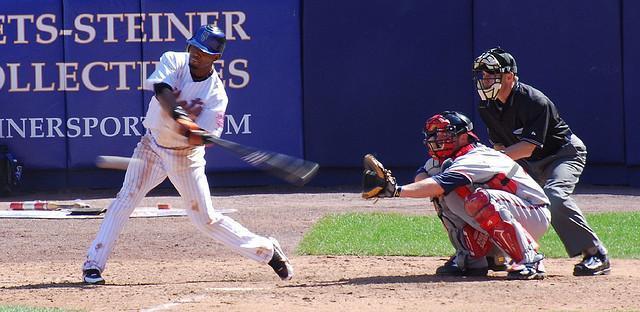How many people are there?
Give a very brief answer. 3. 